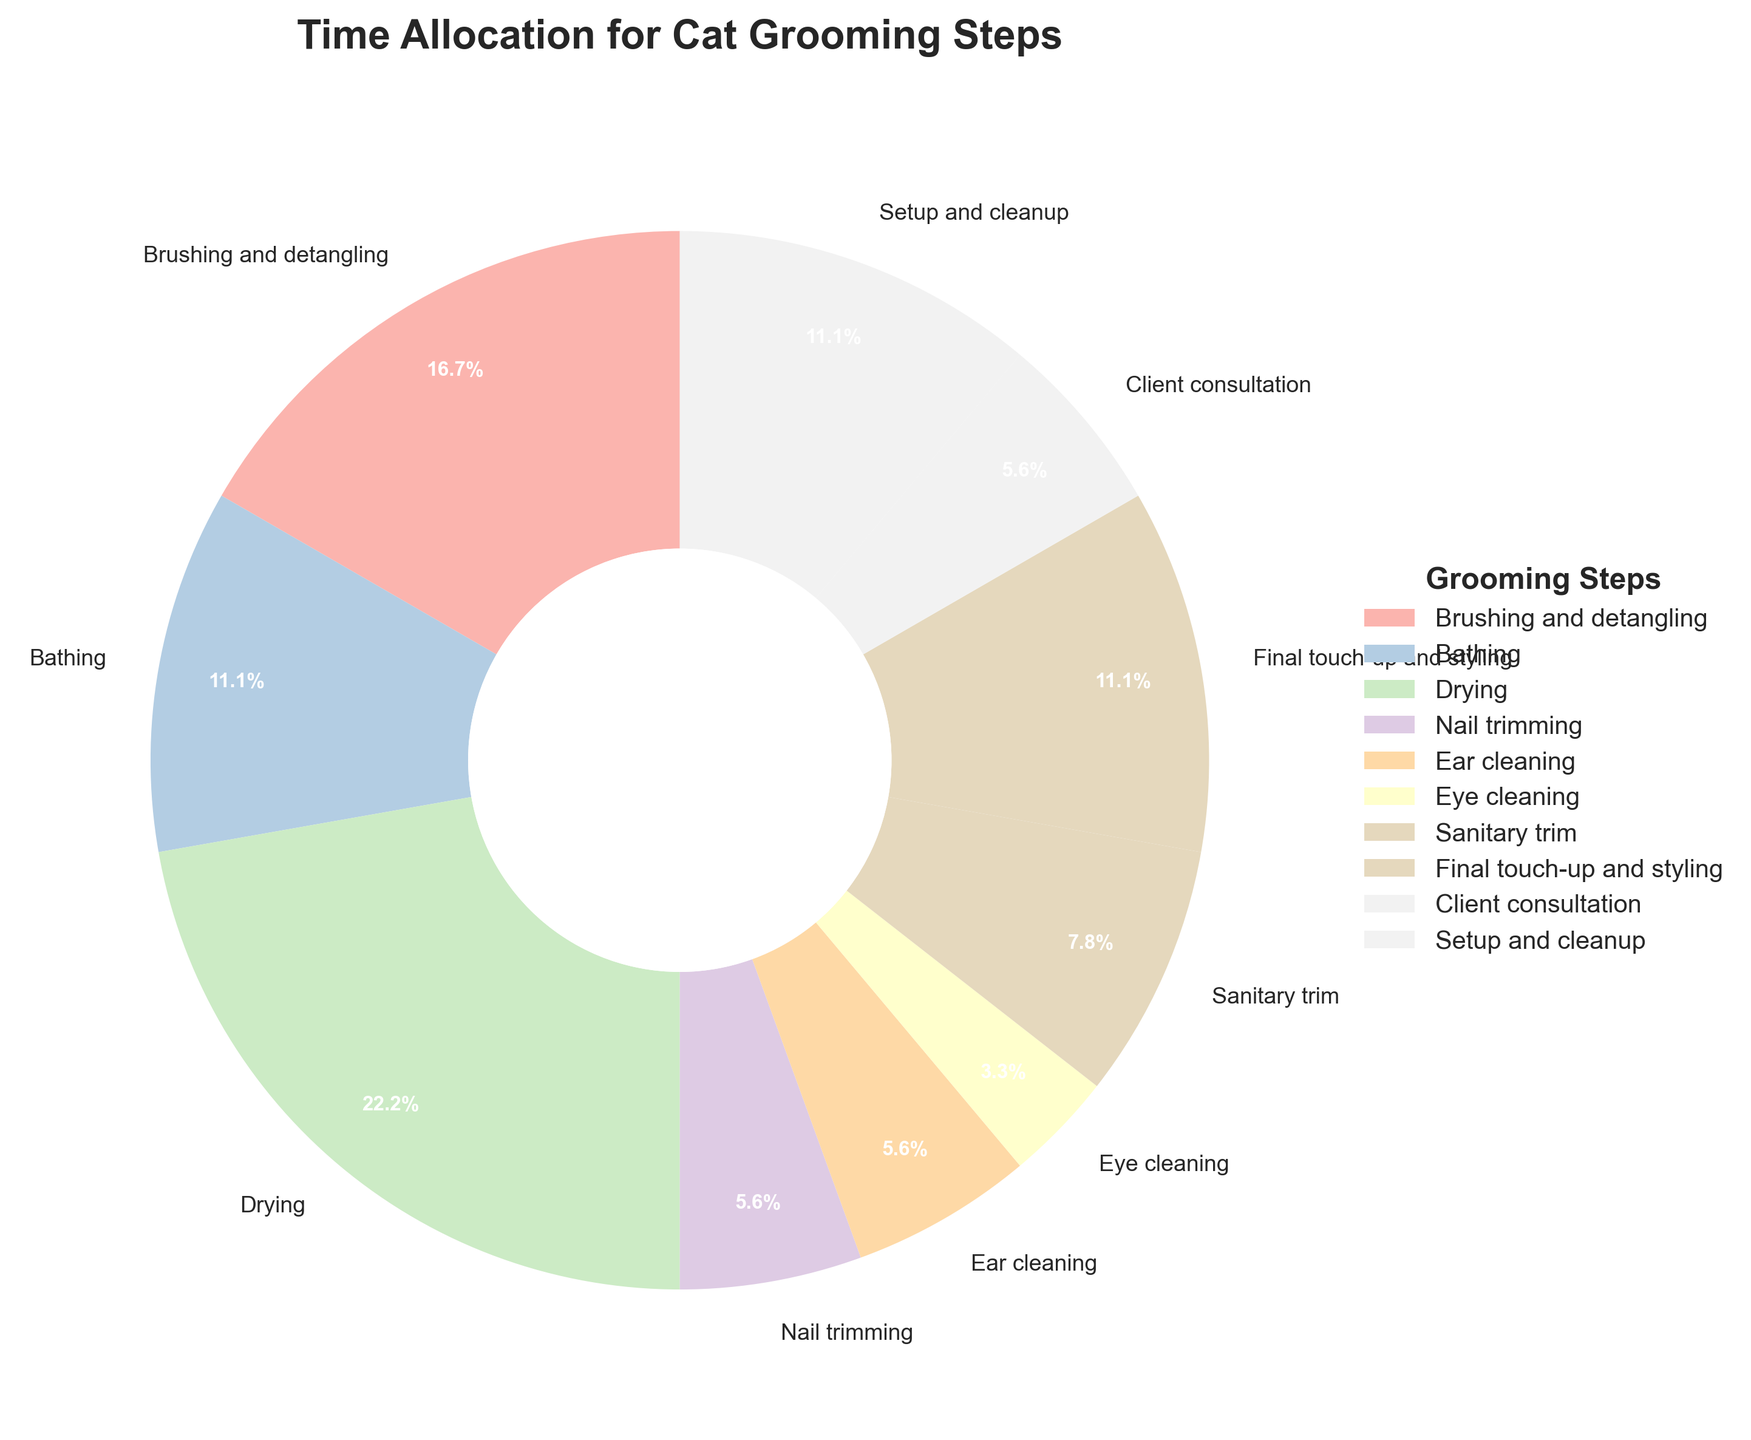what is the total time spent on grooming activities excluding the client consultation and setup and cleanup? To find the total time spent on grooming activities, add the times of all steps excluding client consultation and setup and cleanup. So, 15 + 10 + 20 + 5 + 5 + 3 + 7 + 10 = 75.
Answer: 75 minutes Which step takes the longest time? Looking at the pie chart, the slice representing "Drying" is the largest, indicating it takes the longest time.
Answer: Drying How much more time is spent on drying than on bathing? The time for drying is 20 minutes, and the time for bathing is 10 minutes. Subtracting these gives 20 - 10 = 10 minutes.
Answer: 10 minutes Are there any steps that take an equal amount of time? If yes, which ones? From the pie chart, "Nail trimming," "Ear cleaning," and "Client consultation" each have the same size slice, indicating they each take 5 minutes.
Answer: Nail trimming, Ear cleaning, Client consultation What's the percentage of time spent on final touch-up and styling? The pie chart shows the time for final touch-up and styling given as 10 minutes. The total time for all steps is 90 minutes. So, the percentage is (10 / 90) * 100 = 11.1%.
Answer: 11.1% What's the combined time spent on eye cleaning and sanitary trim? The pie chart shows that the time for eye cleaning is 3 minutes and for sanitary trim is 7 minutes. Adding these together gives 3 + 7 = 10 minutes.
Answer: 10 minutes Is the time spent on brushing and detangling more than the time spent on bathing and ear cleaning combined? Time for brushing and detangling is 15 minutes. Time for bathing and ear cleaning combined is 10 + 5 = 15 minutes. 15 is not more than 15.
Answer: No What fraction of the total time is allocated to setup and cleanup? The time for setup and cleanup is 10 minutes, and the total time is 90 minutes. So the fraction is 10 / 90, which simplifies to 1/9.
Answer: 1/9 Does any step take less than 5% of the total time? If yes, which one? Each step's percentage is calculated as (Step time / Total time * 100). Eye cleaning takes 3 minutes, and the total is 90 minutes. So, (3 / 90) * 100 = 3.3%, which is less than 5%.
Answer: Eye cleaning What is the average time spent on steps that take exactly 5 minutes? Steps taking 5 minutes are nail trimming, ear cleaning, and client consultation. There are 3 such steps, so the total time is 5 + 5 + 5 = 15 minutes. The average is 15 minutes / 3 = 5 minutes.
Answer: 5 minutes 